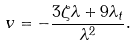Convert formula to latex. <formula><loc_0><loc_0><loc_500><loc_500>v = - \frac { 3 \zeta \lambda + 9 \lambda _ { t } } { \lambda ^ { 2 } } .</formula> 